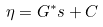<formula> <loc_0><loc_0><loc_500><loc_500>\eta = G ^ { * } s + C</formula> 